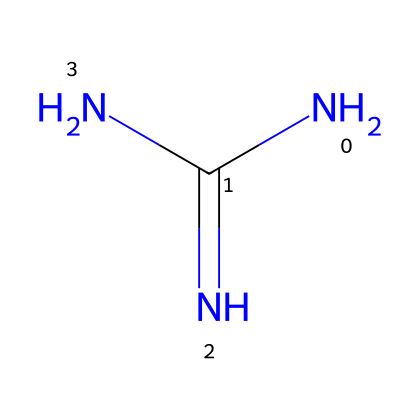What is the name of this compound? The SMILES representation NC(=N)N corresponds to the structure of guanidine, which is a well-known organic base.
Answer: guanidine How many nitrogen atoms are present in the structure? Analyzing the chemical structure, there are a total of three nitrogen atoms represented in the formula NC(=N)N.
Answer: 3 What is the central atom in this chemical structure? The structure shows that the central atom around which other atoms are arranged is carbon (C).
Answer: carbon What type of functional group does guanidine contain? In the chemical structure, the presence of the nitrogen atoms in the arrangement indicates that guanidine contains an amine functional group.
Answer: amine Is guanidine a strong or weak base? Guanidine is recognized as a strong organic base, making it effective for various cleaning applications.
Answer: strong What charges are associated with guanidine in solution? In an aqueous environment, guanidine often exists as a cation due to its strong basic nature, leading to a positive charge.
Answer: cation Which property makes guanidine useful in cleaning products? Guanidine's strong basicity, allowing it to react with acids and break down various organic compounds, makes it useful in cleaning products.
Answer: strong basicity 